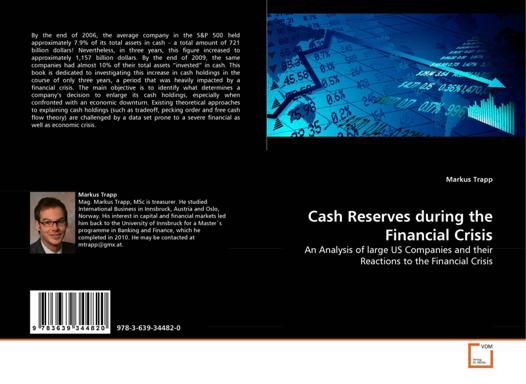What is the title of the book referenced in the image? The title of the book referenced in the image is "Cash Reserves during the Financial Crisis: An Analysis of large US Companies and their Reactions to the Financial Crisis" by Markus Trapp. This book delves into how significant American corporations managed their liquidity during the tumultuous period of the financial crisis, offering a detailed historical and analytical perspective. 